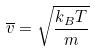<formula> <loc_0><loc_0><loc_500><loc_500>\overline { v } = \sqrt { \frac { k _ { B } T } { m } }</formula> 